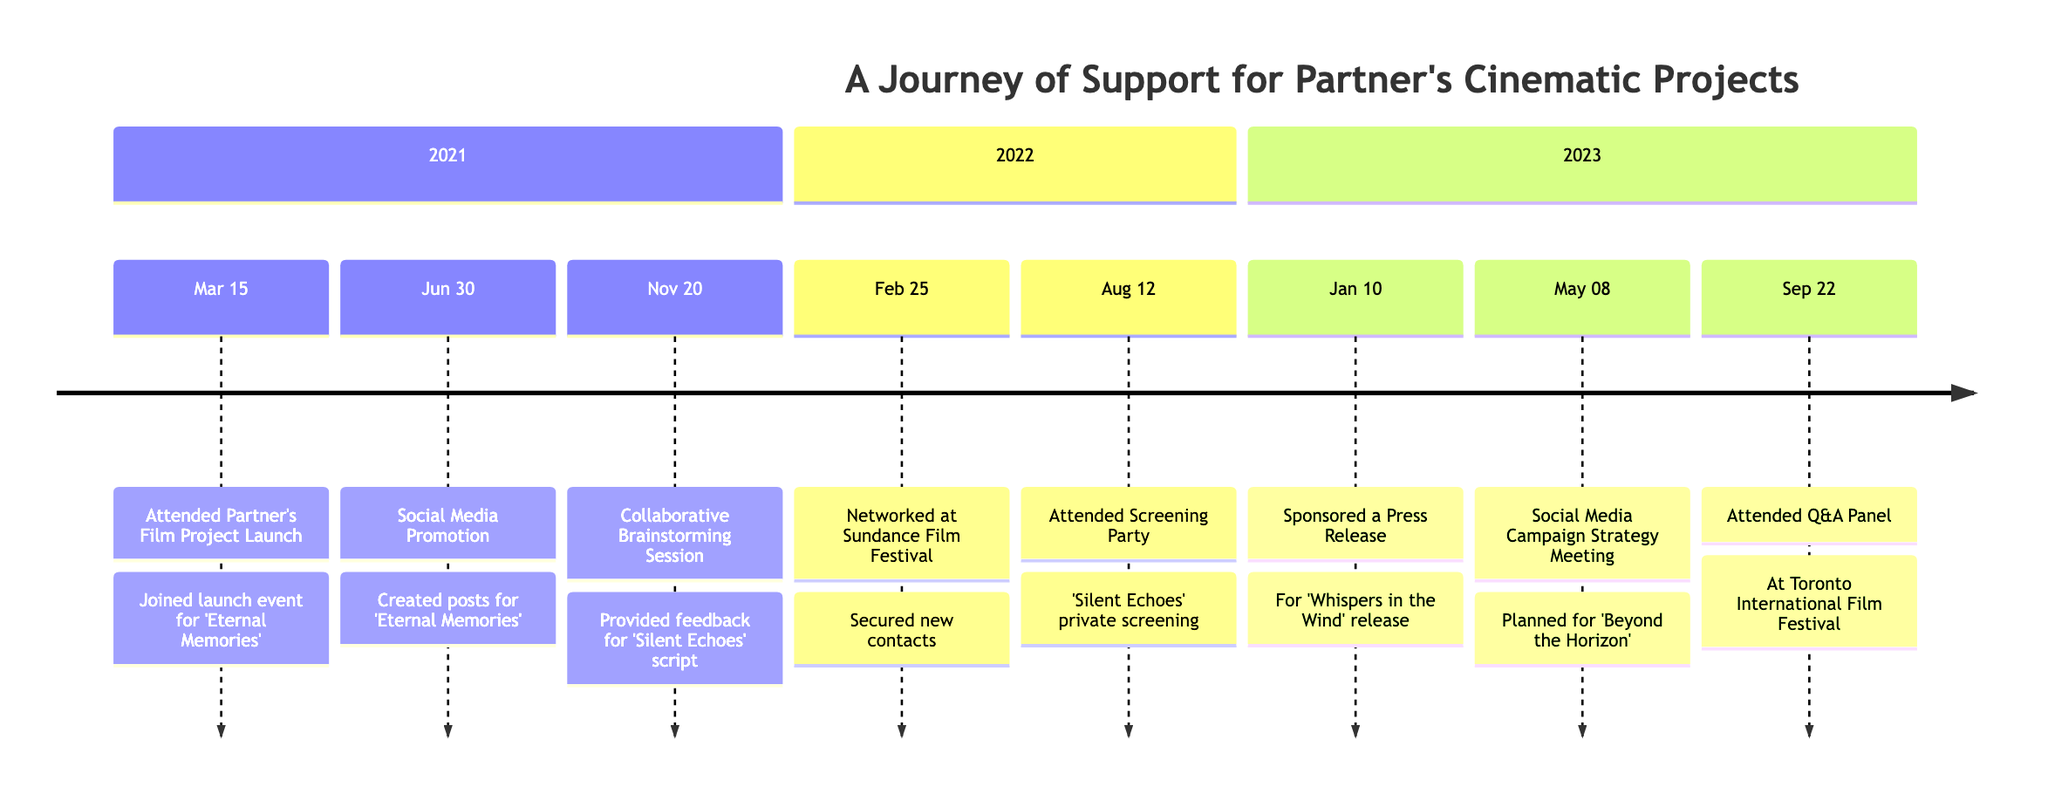What event occurred on March 15, 2021? The timeline clearly indicates that on this date, an event titled "Attended Partner's Film Project Launch" took place, with details mentioning that the individual joined the launch event for "Eternal Memories."
Answer: Attended Partner’s Film Project Launch How many social media promotion events are listed? By scanning the timeline, it's evident that there are two entries related to social media promotion: one for "Eternal Memories" on June 30, 2021, and another for a strategy meeting on May 8, 2023.
Answer: 2 What was the last event recorded in the timeline? The timeline lists events chronologically, with the last date being September 22, 2023. The corresponding event is “Attended Q&A Panel” for "Whispers in the Wind."
Answer: Attended Q&A Panel Which event is associated directly with the documentary 'Beyond the Horizon'? The event relating to 'Beyond the Horizon' is on May 8, 2023, which is about a "Social Media Campaign Strategy Meeting." This specific mention ties it directly to the documentary.
Answer: Social Media Campaign Strategy Meeting In which year was the "Collaborative Brainstorming Session" held? The timeline shows that the "Collaborative Brainstorming Session" occurred on November 20, 2021. Therefore, the year of this event is 2021.
Answer: 2021 How many events happened in 2022? Looking at the timeline, there are two events listed for 2022: one on February 25 and another on August 12. Hence, the count of events in this year is two.
Answer: 2 What was the purpose of the press release sponsored on January 10, 2023? The timeline indicates that the press release sponsored on January 10, 2023, was for the release of "Whispers in the Wind," which clarifies its purpose.
Answer: For the release of 'Whispers in the Wind' What significant film festival is mentioned in the timeline? The timeline highlights the "Sundance Film Festival" as a significant film festival attended on February 25, 2022, during a networking event.
Answer: Sundance Film Festival What event occurred after the "Social Media Promotion"? The timeline shows that the event titled "Collaborative Brainstorming Session" on November 20, 2021, occurred after the "Social Media Promotion" on June 30, 2021.
Answer: Collaborative Brainstorming Session 